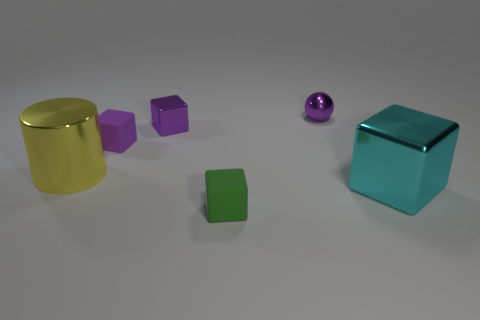Subtract all cyan cubes. How many cubes are left? 3 Subtract 1 cubes. How many cubes are left? 3 Subtract all gray blocks. Subtract all purple cylinders. How many blocks are left? 4 Add 3 large cubes. How many objects exist? 9 Subtract all cylinders. How many objects are left? 5 Subtract 0 red spheres. How many objects are left? 6 Subtract all large yellow things. Subtract all green matte objects. How many objects are left? 4 Add 4 tiny blocks. How many tiny blocks are left? 7 Add 6 big red matte cylinders. How many big red matte cylinders exist? 6 